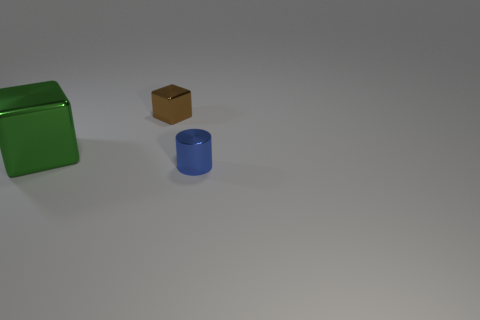Add 2 purple metal cubes. How many objects exist? 5 Subtract all blocks. How many objects are left? 1 Subtract all shiny objects. Subtract all yellow matte spheres. How many objects are left? 0 Add 3 large objects. How many large objects are left? 4 Add 3 big matte cylinders. How many big matte cylinders exist? 3 Subtract 0 yellow spheres. How many objects are left? 3 